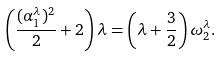Convert formula to latex. <formula><loc_0><loc_0><loc_500><loc_500>\left ( \frac { ( \alpha _ { 1 } ^ { \lambda } ) ^ { 2 } } { 2 } + 2 \right ) \lambda = \left ( \lambda + \frac { 3 } { 2 } \right ) \omega _ { 2 } ^ { \lambda } .</formula> 